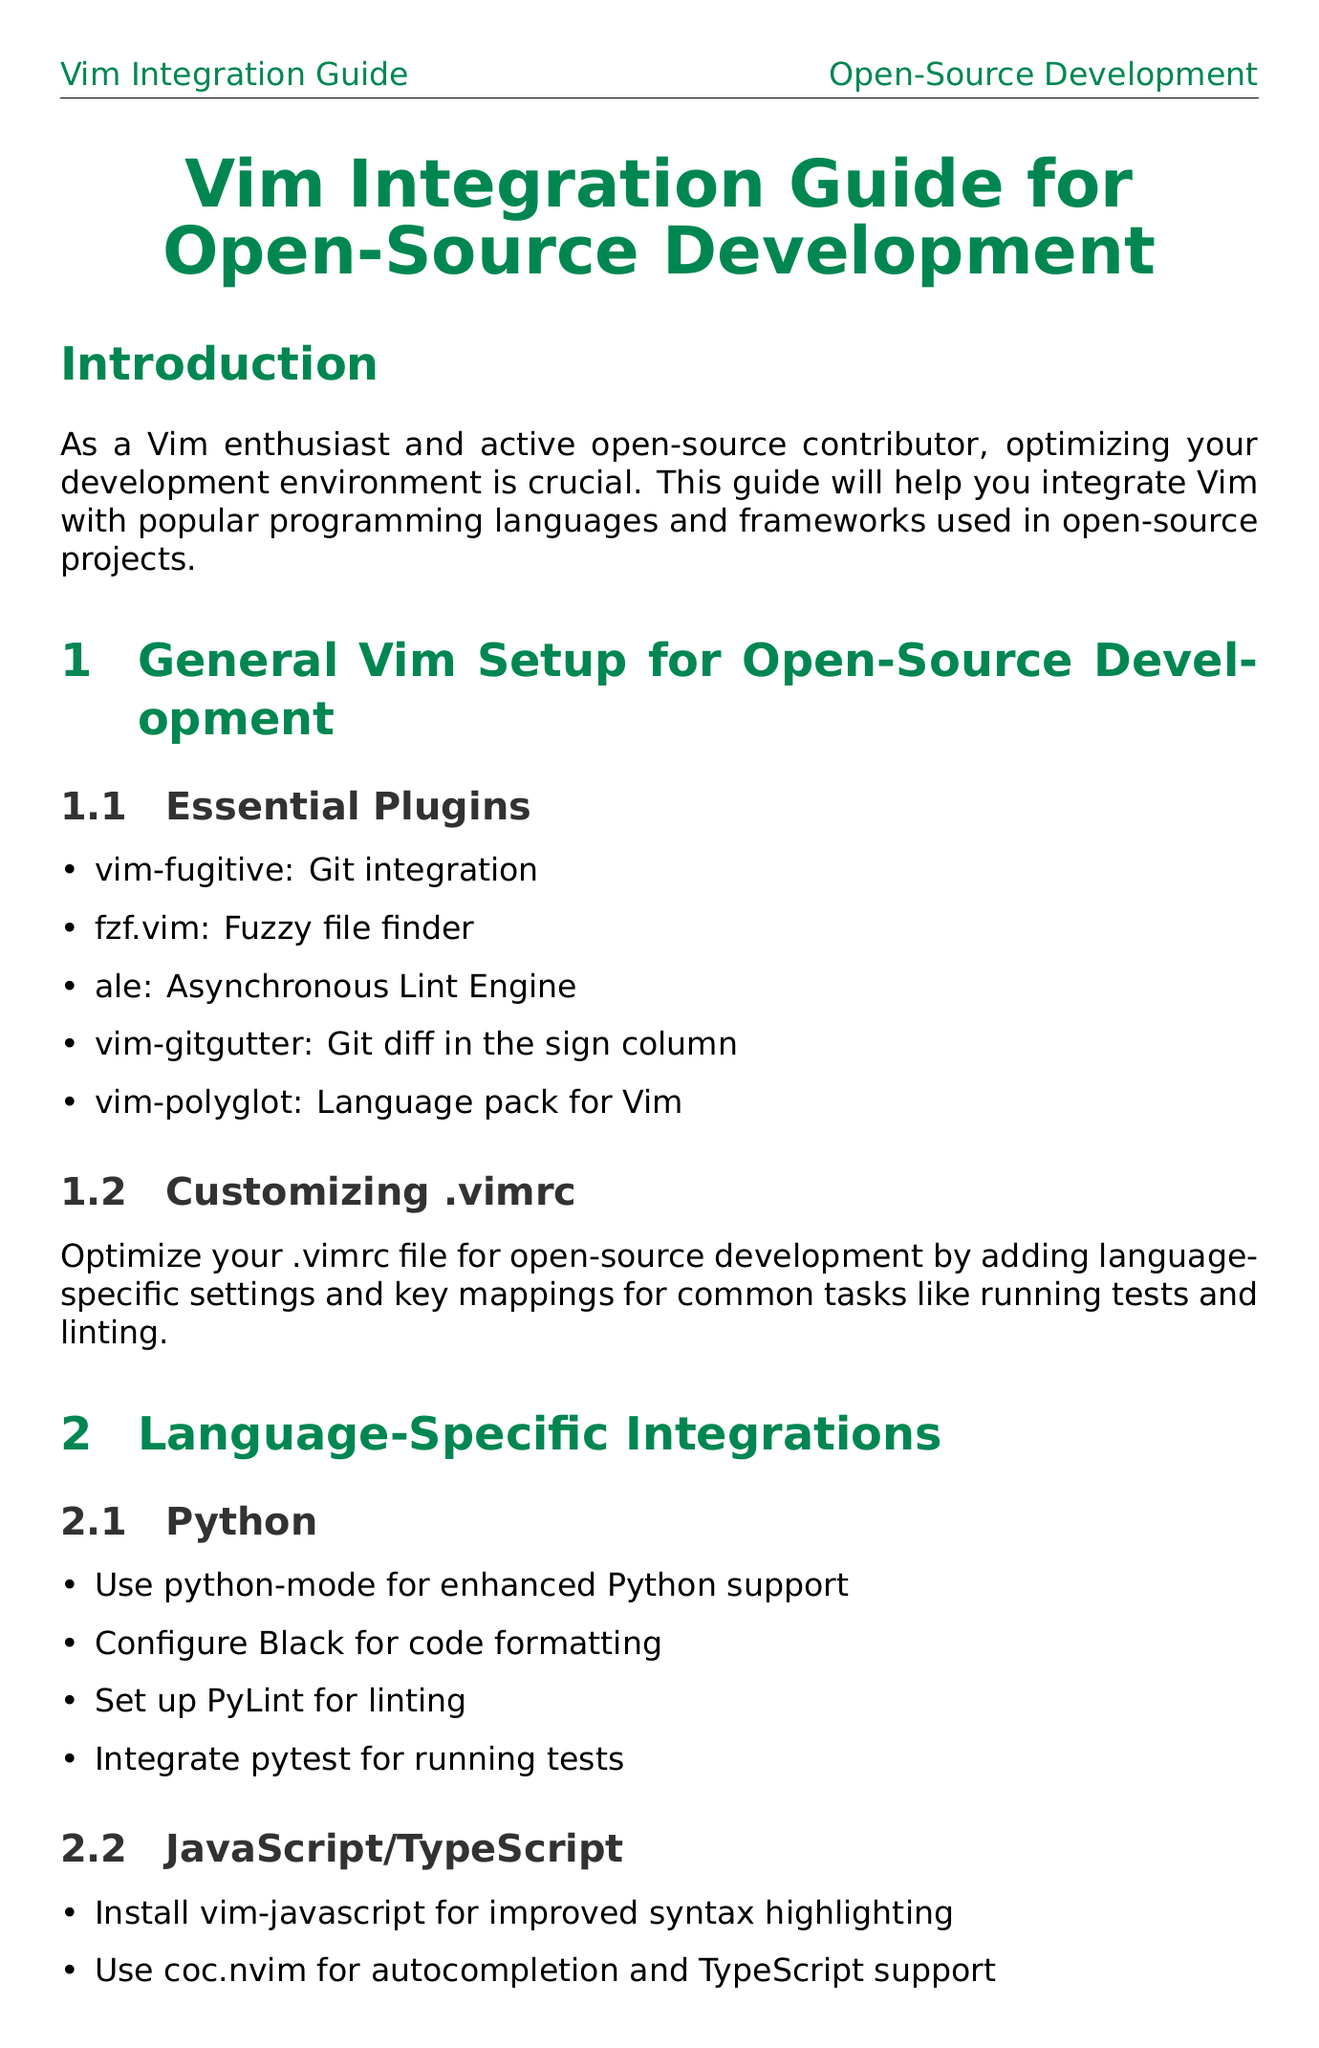What is the title of the document? The title is presented prominently at the beginning of the document.
Answer: Vim Integration Guide for Open-Source Development What plugin is recommended for Git integration? The specific plugin for Git integration is listed under essential plugins.
Answer: vim-fugitive Which language has the integration for pytest? The language-specific integrations section contains a list of tools for different languages, including one for pytest.
Answer: Python How many plugins are listed under Essential Plugins? The number of items in the essential plugins subsection gives the answer.
Answer: Five What is the main purpose of this guide? The introduction section states the objective of the guide.
Answer: Integrate Vim with popular programming languages and frameworks Which framework is associated with RSpec? The framework integrations section mentions tools related to testing for different frameworks.
Answer: Ruby What does the git workflow section leverage? The content of the git workflow subsection details the tool used for Git operations.
Answer: vim-fugitive Which tool is suggested for collaborative editing? The collaborative editing section lists a tool for editing with other contributors.
Answer: tmate What configuration is recommended for the JavaScript/TypeScript integration? The specific configurations are enumerated in the language-specific section for JavaScript/TypeScript.
Answer: ESLint and Prettier 